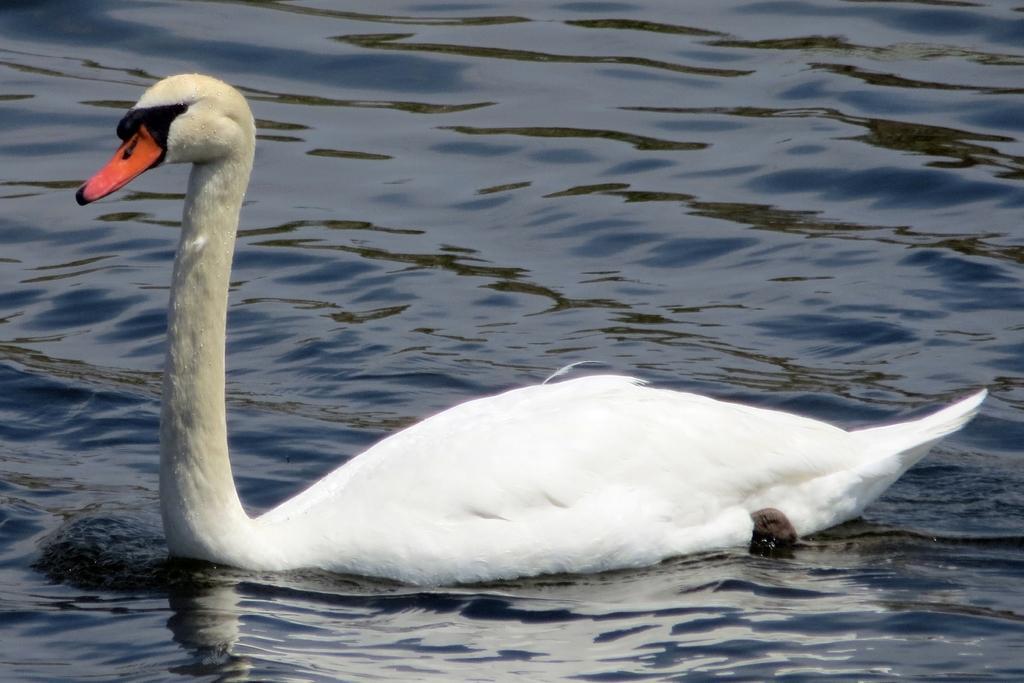In one or two sentences, can you explain what this image depicts? In this image there is a duck in the water. 